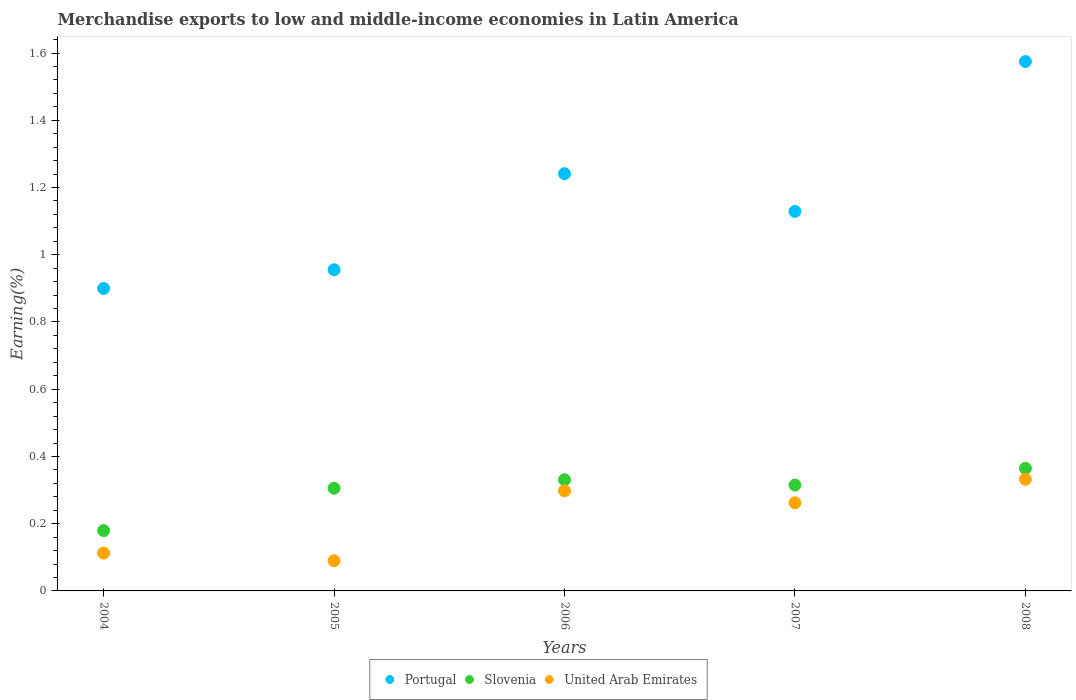Is the number of dotlines equal to the number of legend labels?
Give a very brief answer. Yes. What is the percentage of amount earned from merchandise exports in United Arab Emirates in 2005?
Offer a very short reply. 0.09. Across all years, what is the maximum percentage of amount earned from merchandise exports in Slovenia?
Ensure brevity in your answer.  0.36. Across all years, what is the minimum percentage of amount earned from merchandise exports in Portugal?
Provide a short and direct response. 0.9. In which year was the percentage of amount earned from merchandise exports in United Arab Emirates minimum?
Provide a short and direct response. 2005. What is the total percentage of amount earned from merchandise exports in United Arab Emirates in the graph?
Ensure brevity in your answer.  1.09. What is the difference between the percentage of amount earned from merchandise exports in Portugal in 2005 and that in 2006?
Provide a short and direct response. -0.29. What is the difference between the percentage of amount earned from merchandise exports in Portugal in 2008 and the percentage of amount earned from merchandise exports in United Arab Emirates in 2007?
Make the answer very short. 1.31. What is the average percentage of amount earned from merchandise exports in United Arab Emirates per year?
Offer a very short reply. 0.22. In the year 2004, what is the difference between the percentage of amount earned from merchandise exports in United Arab Emirates and percentage of amount earned from merchandise exports in Slovenia?
Give a very brief answer. -0.07. What is the ratio of the percentage of amount earned from merchandise exports in United Arab Emirates in 2004 to that in 2008?
Your response must be concise. 0.34. Is the difference between the percentage of amount earned from merchandise exports in United Arab Emirates in 2005 and 2007 greater than the difference between the percentage of amount earned from merchandise exports in Slovenia in 2005 and 2007?
Ensure brevity in your answer.  No. What is the difference between the highest and the second highest percentage of amount earned from merchandise exports in Slovenia?
Your answer should be very brief. 0.03. What is the difference between the highest and the lowest percentage of amount earned from merchandise exports in Slovenia?
Offer a terse response. 0.18. In how many years, is the percentage of amount earned from merchandise exports in Portugal greater than the average percentage of amount earned from merchandise exports in Portugal taken over all years?
Keep it short and to the point. 2. Is the sum of the percentage of amount earned from merchandise exports in Slovenia in 2007 and 2008 greater than the maximum percentage of amount earned from merchandise exports in Portugal across all years?
Offer a terse response. No. Is the percentage of amount earned from merchandise exports in United Arab Emirates strictly greater than the percentage of amount earned from merchandise exports in Portugal over the years?
Offer a very short reply. No. How many dotlines are there?
Ensure brevity in your answer.  3. Does the graph contain grids?
Provide a short and direct response. No. Where does the legend appear in the graph?
Keep it short and to the point. Bottom center. What is the title of the graph?
Provide a succinct answer. Merchandise exports to low and middle-income economies in Latin America. What is the label or title of the Y-axis?
Your answer should be very brief. Earning(%). What is the Earning(%) in Portugal in 2004?
Keep it short and to the point. 0.9. What is the Earning(%) of Slovenia in 2004?
Ensure brevity in your answer.  0.18. What is the Earning(%) in United Arab Emirates in 2004?
Make the answer very short. 0.11. What is the Earning(%) in Portugal in 2005?
Your response must be concise. 0.96. What is the Earning(%) of Slovenia in 2005?
Make the answer very short. 0.31. What is the Earning(%) in United Arab Emirates in 2005?
Provide a short and direct response. 0.09. What is the Earning(%) in Portugal in 2006?
Your answer should be compact. 1.24. What is the Earning(%) of Slovenia in 2006?
Keep it short and to the point. 0.33. What is the Earning(%) in United Arab Emirates in 2006?
Provide a succinct answer. 0.3. What is the Earning(%) of Portugal in 2007?
Offer a terse response. 1.13. What is the Earning(%) of Slovenia in 2007?
Give a very brief answer. 0.31. What is the Earning(%) in United Arab Emirates in 2007?
Offer a very short reply. 0.26. What is the Earning(%) in Portugal in 2008?
Your response must be concise. 1.57. What is the Earning(%) of Slovenia in 2008?
Give a very brief answer. 0.36. What is the Earning(%) of United Arab Emirates in 2008?
Ensure brevity in your answer.  0.33. Across all years, what is the maximum Earning(%) of Portugal?
Make the answer very short. 1.57. Across all years, what is the maximum Earning(%) of Slovenia?
Provide a short and direct response. 0.36. Across all years, what is the maximum Earning(%) of United Arab Emirates?
Provide a short and direct response. 0.33. Across all years, what is the minimum Earning(%) of Portugal?
Your response must be concise. 0.9. Across all years, what is the minimum Earning(%) of Slovenia?
Offer a terse response. 0.18. Across all years, what is the minimum Earning(%) of United Arab Emirates?
Offer a terse response. 0.09. What is the total Earning(%) of Portugal in the graph?
Provide a succinct answer. 5.8. What is the total Earning(%) in Slovenia in the graph?
Keep it short and to the point. 1.49. What is the total Earning(%) in United Arab Emirates in the graph?
Make the answer very short. 1.09. What is the difference between the Earning(%) of Portugal in 2004 and that in 2005?
Give a very brief answer. -0.06. What is the difference between the Earning(%) of Slovenia in 2004 and that in 2005?
Your response must be concise. -0.13. What is the difference between the Earning(%) in United Arab Emirates in 2004 and that in 2005?
Your response must be concise. 0.02. What is the difference between the Earning(%) in Portugal in 2004 and that in 2006?
Offer a terse response. -0.34. What is the difference between the Earning(%) in Slovenia in 2004 and that in 2006?
Offer a very short reply. -0.15. What is the difference between the Earning(%) of United Arab Emirates in 2004 and that in 2006?
Offer a terse response. -0.19. What is the difference between the Earning(%) of Portugal in 2004 and that in 2007?
Offer a very short reply. -0.23. What is the difference between the Earning(%) of Slovenia in 2004 and that in 2007?
Your response must be concise. -0.14. What is the difference between the Earning(%) of United Arab Emirates in 2004 and that in 2007?
Keep it short and to the point. -0.15. What is the difference between the Earning(%) of Portugal in 2004 and that in 2008?
Your response must be concise. -0.68. What is the difference between the Earning(%) in Slovenia in 2004 and that in 2008?
Make the answer very short. -0.18. What is the difference between the Earning(%) of United Arab Emirates in 2004 and that in 2008?
Ensure brevity in your answer.  -0.22. What is the difference between the Earning(%) of Portugal in 2005 and that in 2006?
Your answer should be very brief. -0.29. What is the difference between the Earning(%) of Slovenia in 2005 and that in 2006?
Your response must be concise. -0.03. What is the difference between the Earning(%) of United Arab Emirates in 2005 and that in 2006?
Provide a short and direct response. -0.21. What is the difference between the Earning(%) of Portugal in 2005 and that in 2007?
Make the answer very short. -0.17. What is the difference between the Earning(%) of Slovenia in 2005 and that in 2007?
Your response must be concise. -0.01. What is the difference between the Earning(%) of United Arab Emirates in 2005 and that in 2007?
Make the answer very short. -0.17. What is the difference between the Earning(%) of Portugal in 2005 and that in 2008?
Provide a succinct answer. -0.62. What is the difference between the Earning(%) of Slovenia in 2005 and that in 2008?
Offer a terse response. -0.06. What is the difference between the Earning(%) in United Arab Emirates in 2005 and that in 2008?
Your response must be concise. -0.24. What is the difference between the Earning(%) of Portugal in 2006 and that in 2007?
Make the answer very short. 0.11. What is the difference between the Earning(%) in Slovenia in 2006 and that in 2007?
Keep it short and to the point. 0.02. What is the difference between the Earning(%) in United Arab Emirates in 2006 and that in 2007?
Your answer should be very brief. 0.04. What is the difference between the Earning(%) in Portugal in 2006 and that in 2008?
Make the answer very short. -0.33. What is the difference between the Earning(%) of Slovenia in 2006 and that in 2008?
Offer a terse response. -0.03. What is the difference between the Earning(%) in United Arab Emirates in 2006 and that in 2008?
Offer a very short reply. -0.03. What is the difference between the Earning(%) in Portugal in 2007 and that in 2008?
Offer a very short reply. -0.45. What is the difference between the Earning(%) of Slovenia in 2007 and that in 2008?
Provide a short and direct response. -0.05. What is the difference between the Earning(%) in United Arab Emirates in 2007 and that in 2008?
Your answer should be very brief. -0.07. What is the difference between the Earning(%) in Portugal in 2004 and the Earning(%) in Slovenia in 2005?
Your response must be concise. 0.59. What is the difference between the Earning(%) in Portugal in 2004 and the Earning(%) in United Arab Emirates in 2005?
Your response must be concise. 0.81. What is the difference between the Earning(%) of Slovenia in 2004 and the Earning(%) of United Arab Emirates in 2005?
Provide a short and direct response. 0.09. What is the difference between the Earning(%) of Portugal in 2004 and the Earning(%) of Slovenia in 2006?
Provide a short and direct response. 0.57. What is the difference between the Earning(%) of Portugal in 2004 and the Earning(%) of United Arab Emirates in 2006?
Your response must be concise. 0.6. What is the difference between the Earning(%) in Slovenia in 2004 and the Earning(%) in United Arab Emirates in 2006?
Provide a succinct answer. -0.12. What is the difference between the Earning(%) in Portugal in 2004 and the Earning(%) in Slovenia in 2007?
Your response must be concise. 0.58. What is the difference between the Earning(%) in Portugal in 2004 and the Earning(%) in United Arab Emirates in 2007?
Your response must be concise. 0.64. What is the difference between the Earning(%) in Slovenia in 2004 and the Earning(%) in United Arab Emirates in 2007?
Provide a short and direct response. -0.08. What is the difference between the Earning(%) of Portugal in 2004 and the Earning(%) of Slovenia in 2008?
Offer a terse response. 0.54. What is the difference between the Earning(%) of Portugal in 2004 and the Earning(%) of United Arab Emirates in 2008?
Ensure brevity in your answer.  0.57. What is the difference between the Earning(%) of Slovenia in 2004 and the Earning(%) of United Arab Emirates in 2008?
Provide a short and direct response. -0.15. What is the difference between the Earning(%) in Portugal in 2005 and the Earning(%) in Slovenia in 2006?
Provide a short and direct response. 0.62. What is the difference between the Earning(%) in Portugal in 2005 and the Earning(%) in United Arab Emirates in 2006?
Ensure brevity in your answer.  0.66. What is the difference between the Earning(%) of Slovenia in 2005 and the Earning(%) of United Arab Emirates in 2006?
Offer a very short reply. 0.01. What is the difference between the Earning(%) of Portugal in 2005 and the Earning(%) of Slovenia in 2007?
Provide a succinct answer. 0.64. What is the difference between the Earning(%) in Portugal in 2005 and the Earning(%) in United Arab Emirates in 2007?
Ensure brevity in your answer.  0.69. What is the difference between the Earning(%) in Slovenia in 2005 and the Earning(%) in United Arab Emirates in 2007?
Your answer should be compact. 0.04. What is the difference between the Earning(%) in Portugal in 2005 and the Earning(%) in Slovenia in 2008?
Give a very brief answer. 0.59. What is the difference between the Earning(%) of Portugal in 2005 and the Earning(%) of United Arab Emirates in 2008?
Give a very brief answer. 0.62. What is the difference between the Earning(%) of Slovenia in 2005 and the Earning(%) of United Arab Emirates in 2008?
Ensure brevity in your answer.  -0.03. What is the difference between the Earning(%) in Portugal in 2006 and the Earning(%) in Slovenia in 2007?
Provide a short and direct response. 0.93. What is the difference between the Earning(%) in Portugal in 2006 and the Earning(%) in United Arab Emirates in 2007?
Give a very brief answer. 0.98. What is the difference between the Earning(%) of Slovenia in 2006 and the Earning(%) of United Arab Emirates in 2007?
Make the answer very short. 0.07. What is the difference between the Earning(%) of Portugal in 2006 and the Earning(%) of Slovenia in 2008?
Offer a very short reply. 0.88. What is the difference between the Earning(%) in Portugal in 2006 and the Earning(%) in United Arab Emirates in 2008?
Provide a succinct answer. 0.91. What is the difference between the Earning(%) in Slovenia in 2006 and the Earning(%) in United Arab Emirates in 2008?
Provide a short and direct response. -0. What is the difference between the Earning(%) of Portugal in 2007 and the Earning(%) of Slovenia in 2008?
Offer a very short reply. 0.76. What is the difference between the Earning(%) of Portugal in 2007 and the Earning(%) of United Arab Emirates in 2008?
Your answer should be compact. 0.8. What is the difference between the Earning(%) of Slovenia in 2007 and the Earning(%) of United Arab Emirates in 2008?
Give a very brief answer. -0.02. What is the average Earning(%) of Portugal per year?
Give a very brief answer. 1.16. What is the average Earning(%) of Slovenia per year?
Make the answer very short. 0.3. What is the average Earning(%) of United Arab Emirates per year?
Keep it short and to the point. 0.22. In the year 2004, what is the difference between the Earning(%) in Portugal and Earning(%) in Slovenia?
Offer a very short reply. 0.72. In the year 2004, what is the difference between the Earning(%) of Portugal and Earning(%) of United Arab Emirates?
Offer a terse response. 0.79. In the year 2004, what is the difference between the Earning(%) of Slovenia and Earning(%) of United Arab Emirates?
Your response must be concise. 0.07. In the year 2005, what is the difference between the Earning(%) of Portugal and Earning(%) of Slovenia?
Ensure brevity in your answer.  0.65. In the year 2005, what is the difference between the Earning(%) in Portugal and Earning(%) in United Arab Emirates?
Your answer should be very brief. 0.87. In the year 2005, what is the difference between the Earning(%) in Slovenia and Earning(%) in United Arab Emirates?
Your answer should be very brief. 0.22. In the year 2006, what is the difference between the Earning(%) in Portugal and Earning(%) in Slovenia?
Your response must be concise. 0.91. In the year 2006, what is the difference between the Earning(%) in Portugal and Earning(%) in United Arab Emirates?
Your answer should be compact. 0.94. In the year 2006, what is the difference between the Earning(%) in Slovenia and Earning(%) in United Arab Emirates?
Offer a very short reply. 0.03. In the year 2007, what is the difference between the Earning(%) of Portugal and Earning(%) of Slovenia?
Your response must be concise. 0.81. In the year 2007, what is the difference between the Earning(%) in Portugal and Earning(%) in United Arab Emirates?
Your response must be concise. 0.87. In the year 2007, what is the difference between the Earning(%) in Slovenia and Earning(%) in United Arab Emirates?
Offer a very short reply. 0.05. In the year 2008, what is the difference between the Earning(%) in Portugal and Earning(%) in Slovenia?
Provide a succinct answer. 1.21. In the year 2008, what is the difference between the Earning(%) in Portugal and Earning(%) in United Arab Emirates?
Give a very brief answer. 1.24. In the year 2008, what is the difference between the Earning(%) in Slovenia and Earning(%) in United Arab Emirates?
Your answer should be very brief. 0.03. What is the ratio of the Earning(%) of Portugal in 2004 to that in 2005?
Give a very brief answer. 0.94. What is the ratio of the Earning(%) in Slovenia in 2004 to that in 2005?
Offer a terse response. 0.59. What is the ratio of the Earning(%) of United Arab Emirates in 2004 to that in 2005?
Make the answer very short. 1.26. What is the ratio of the Earning(%) of Portugal in 2004 to that in 2006?
Provide a short and direct response. 0.72. What is the ratio of the Earning(%) in Slovenia in 2004 to that in 2006?
Make the answer very short. 0.54. What is the ratio of the Earning(%) in United Arab Emirates in 2004 to that in 2006?
Keep it short and to the point. 0.38. What is the ratio of the Earning(%) in Portugal in 2004 to that in 2007?
Give a very brief answer. 0.8. What is the ratio of the Earning(%) in Slovenia in 2004 to that in 2007?
Offer a very short reply. 0.57. What is the ratio of the Earning(%) of United Arab Emirates in 2004 to that in 2007?
Your answer should be compact. 0.43. What is the ratio of the Earning(%) of Portugal in 2004 to that in 2008?
Your response must be concise. 0.57. What is the ratio of the Earning(%) in Slovenia in 2004 to that in 2008?
Offer a very short reply. 0.49. What is the ratio of the Earning(%) in United Arab Emirates in 2004 to that in 2008?
Ensure brevity in your answer.  0.34. What is the ratio of the Earning(%) of Portugal in 2005 to that in 2006?
Provide a succinct answer. 0.77. What is the ratio of the Earning(%) in Slovenia in 2005 to that in 2006?
Give a very brief answer. 0.92. What is the ratio of the Earning(%) of United Arab Emirates in 2005 to that in 2006?
Give a very brief answer. 0.3. What is the ratio of the Earning(%) of Portugal in 2005 to that in 2007?
Ensure brevity in your answer.  0.85. What is the ratio of the Earning(%) of United Arab Emirates in 2005 to that in 2007?
Keep it short and to the point. 0.34. What is the ratio of the Earning(%) in Portugal in 2005 to that in 2008?
Your answer should be compact. 0.61. What is the ratio of the Earning(%) of Slovenia in 2005 to that in 2008?
Your response must be concise. 0.84. What is the ratio of the Earning(%) in United Arab Emirates in 2005 to that in 2008?
Keep it short and to the point. 0.27. What is the ratio of the Earning(%) in Portugal in 2006 to that in 2007?
Offer a very short reply. 1.1. What is the ratio of the Earning(%) in United Arab Emirates in 2006 to that in 2007?
Offer a very short reply. 1.14. What is the ratio of the Earning(%) in Portugal in 2006 to that in 2008?
Give a very brief answer. 0.79. What is the ratio of the Earning(%) in Slovenia in 2006 to that in 2008?
Provide a short and direct response. 0.91. What is the ratio of the Earning(%) of United Arab Emirates in 2006 to that in 2008?
Offer a terse response. 0.9. What is the ratio of the Earning(%) of Portugal in 2007 to that in 2008?
Your answer should be compact. 0.72. What is the ratio of the Earning(%) in Slovenia in 2007 to that in 2008?
Your answer should be compact. 0.86. What is the ratio of the Earning(%) of United Arab Emirates in 2007 to that in 2008?
Ensure brevity in your answer.  0.79. What is the difference between the highest and the second highest Earning(%) in Portugal?
Ensure brevity in your answer.  0.33. What is the difference between the highest and the second highest Earning(%) of Slovenia?
Ensure brevity in your answer.  0.03. What is the difference between the highest and the second highest Earning(%) in United Arab Emirates?
Your answer should be compact. 0.03. What is the difference between the highest and the lowest Earning(%) in Portugal?
Keep it short and to the point. 0.68. What is the difference between the highest and the lowest Earning(%) in Slovenia?
Your answer should be compact. 0.18. What is the difference between the highest and the lowest Earning(%) of United Arab Emirates?
Give a very brief answer. 0.24. 